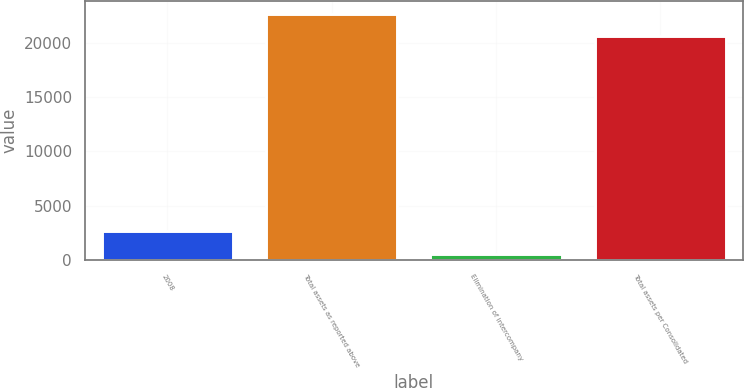Convert chart to OTSL. <chart><loc_0><loc_0><loc_500><loc_500><bar_chart><fcel>2008<fcel>Total assets as reported above<fcel>Elimination of intercompany<fcel>Total assets per Consolidated<nl><fcel>2642<fcel>22660<fcel>582<fcel>20600<nl></chart> 